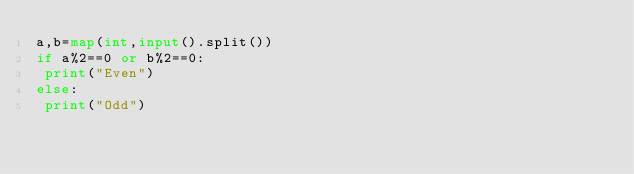<code> <loc_0><loc_0><loc_500><loc_500><_Python_>a,b=map(int,input().split())
if a%2==0 or b%2==0:
 print("Even")
else:
 print("Odd")</code> 